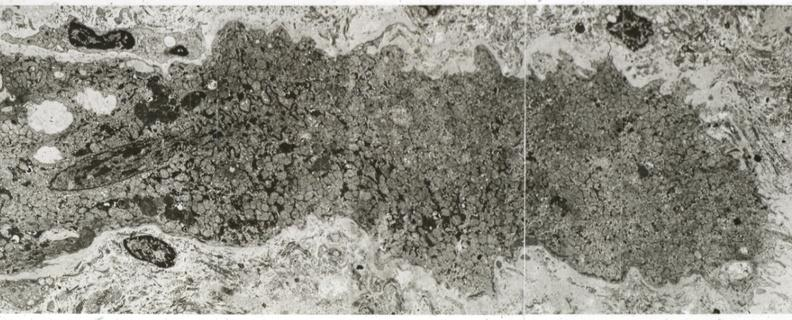s cardiovascular present?
Answer the question using a single word or phrase. Yes 